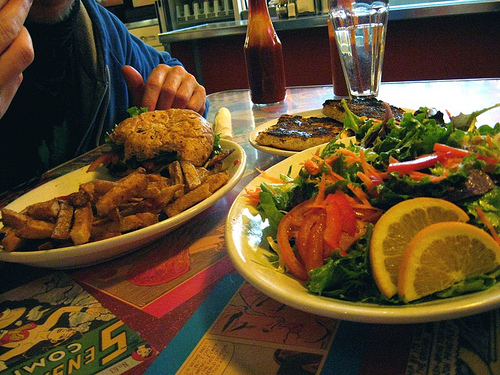<image>
Is there a ketchup on the fries? No. The ketchup is not positioned on the fries. They may be near each other, but the ketchup is not supported by or resting on top of the fries. 